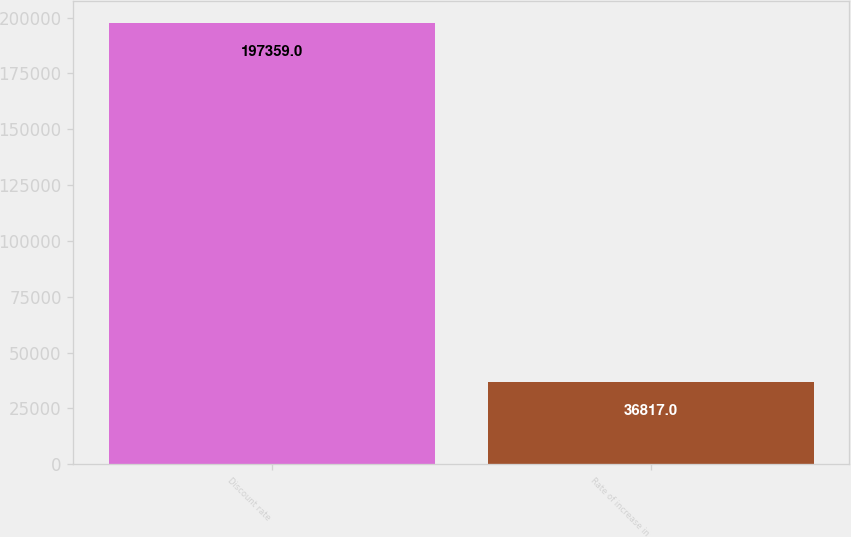<chart> <loc_0><loc_0><loc_500><loc_500><bar_chart><fcel>Discount rate<fcel>Rate of increase in<nl><fcel>197359<fcel>36817<nl></chart> 